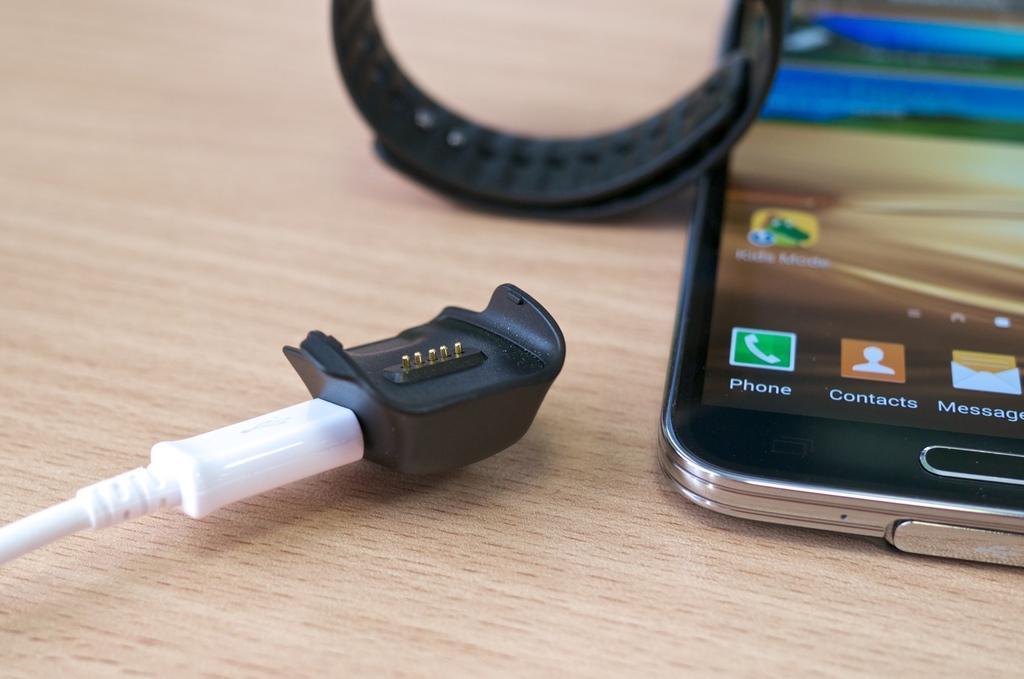Describe this image in one or two sentences. This image consists of a mobile, and a watch along with cable are kept on the table which is made up of wood. 